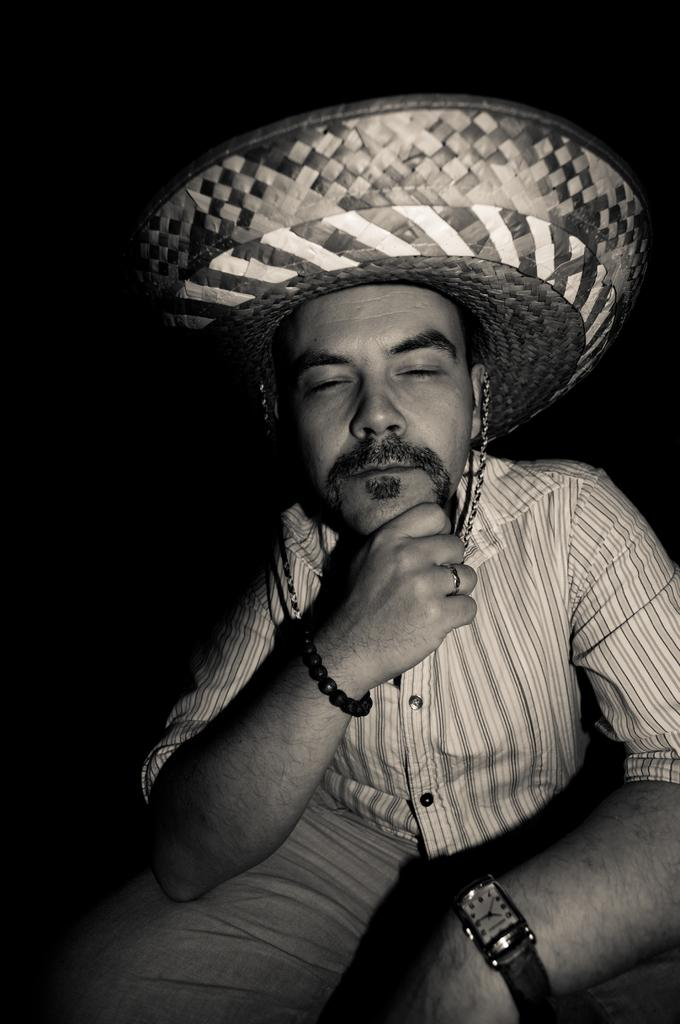What can be seen in the image? There is a person in the image. What is the person wearing on their head? The person is wearing a hat. What can be observed about the background of the image? The background of the image is dark. What type of lunchroom is depicted in the image? There is no lunchroom present in the image; it features a person wearing a hat against a dark background. 